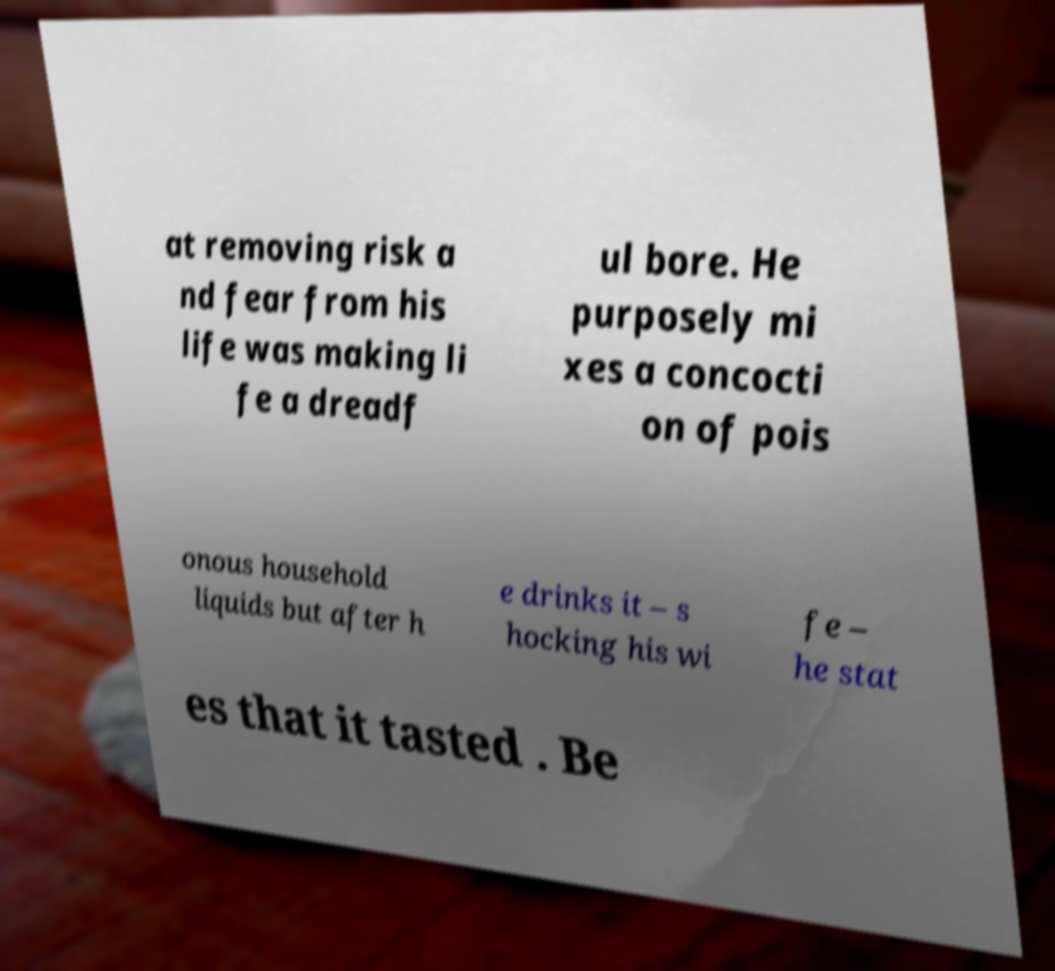Please read and relay the text visible in this image. What does it say? at removing risk a nd fear from his life was making li fe a dreadf ul bore. He purposely mi xes a concocti on of pois onous household liquids but after h e drinks it – s hocking his wi fe – he stat es that it tasted . Be 